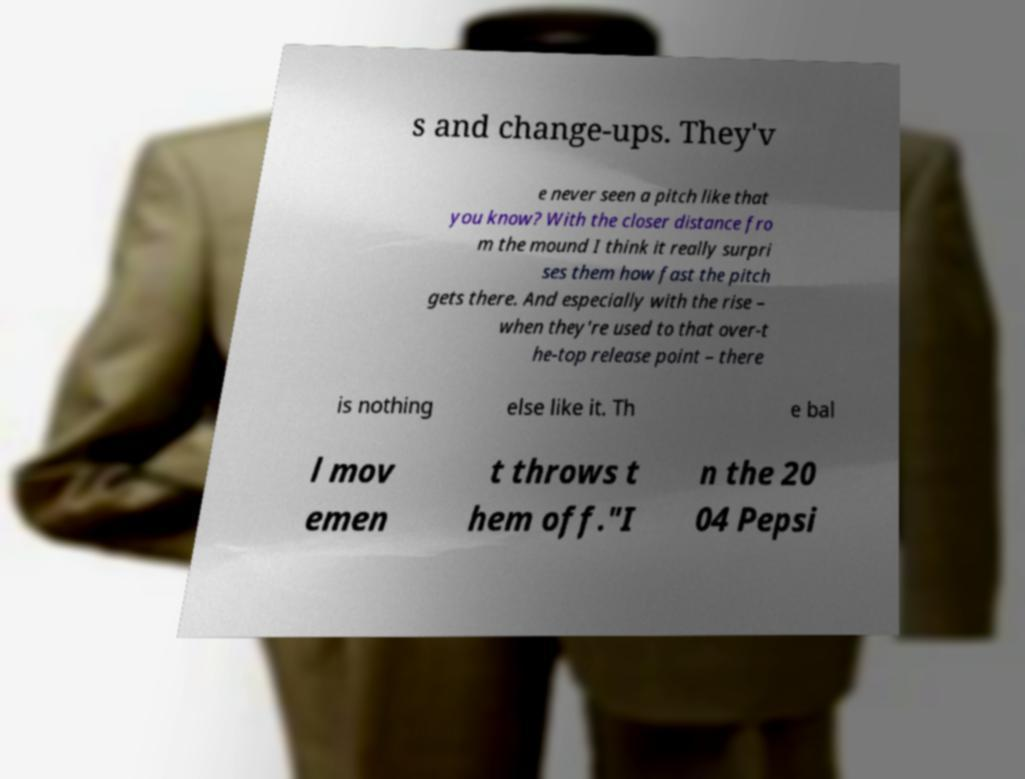Can you accurately transcribe the text from the provided image for me? s and change-ups. They'v e never seen a pitch like that you know? With the closer distance fro m the mound I think it really surpri ses them how fast the pitch gets there. And especially with the rise – when they're used to that over-t he-top release point – there is nothing else like it. Th e bal l mov emen t throws t hem off."I n the 20 04 Pepsi 